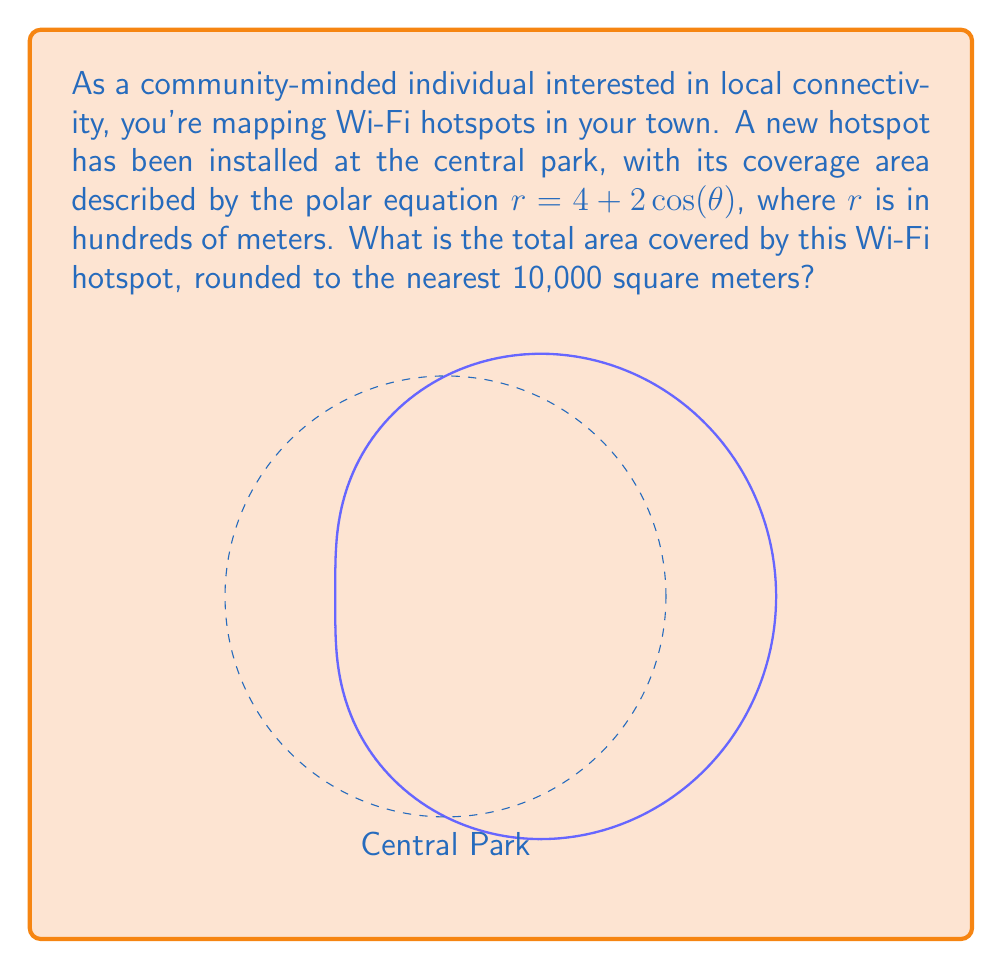Can you answer this question? Let's approach this step-by-step:

1) The area of a region in polar coordinates is given by the formula:

   $$A = \frac{1}{2} \int_0^{2\pi} r^2(\theta) d\theta$$

2) In our case, $r(\theta) = 4 + 2\cos(\theta)$. We need to square this:

   $$r^2(\theta) = (4 + 2\cos(\theta))^2 = 16 + 16\cos(\theta) + 4\cos^2(\theta)$$

3) Now, let's set up our integral:

   $$A = \frac{1}{2} \int_0^{2\pi} (16 + 16\cos(\theta) + 4\cos^2(\theta)) d\theta$$

4) Let's integrate each term:
   
   - $\int_0^{2\pi} 16 d\theta = 16\theta |_0^{2\pi} = 32\pi$
   - $\int_0^{2\pi} 16\cos(\theta) d\theta = 16\sin(\theta) |_0^{2\pi} = 0$
   - $\int_0^{2\pi} 4\cos^2(\theta) d\theta = 2\theta + 2\sin(\theta)\cos(\theta) |_0^{2\pi} = 4\pi$

5) Adding these up:

   $$A = \frac{1}{2} (32\pi + 0 + 4\pi) = 18\pi$$

6) Remember, $r$ was in hundreds of meters, so our area is in 10,000 square meters. Therefore:

   $$A = 18\pi * 10,000 \approx 565,487 \text{ square meters}$$

7) Rounding to the nearest 10,000 square meters:

   $$A \approx 570,000 \text{ square meters}$$
Answer: 570,000 square meters 